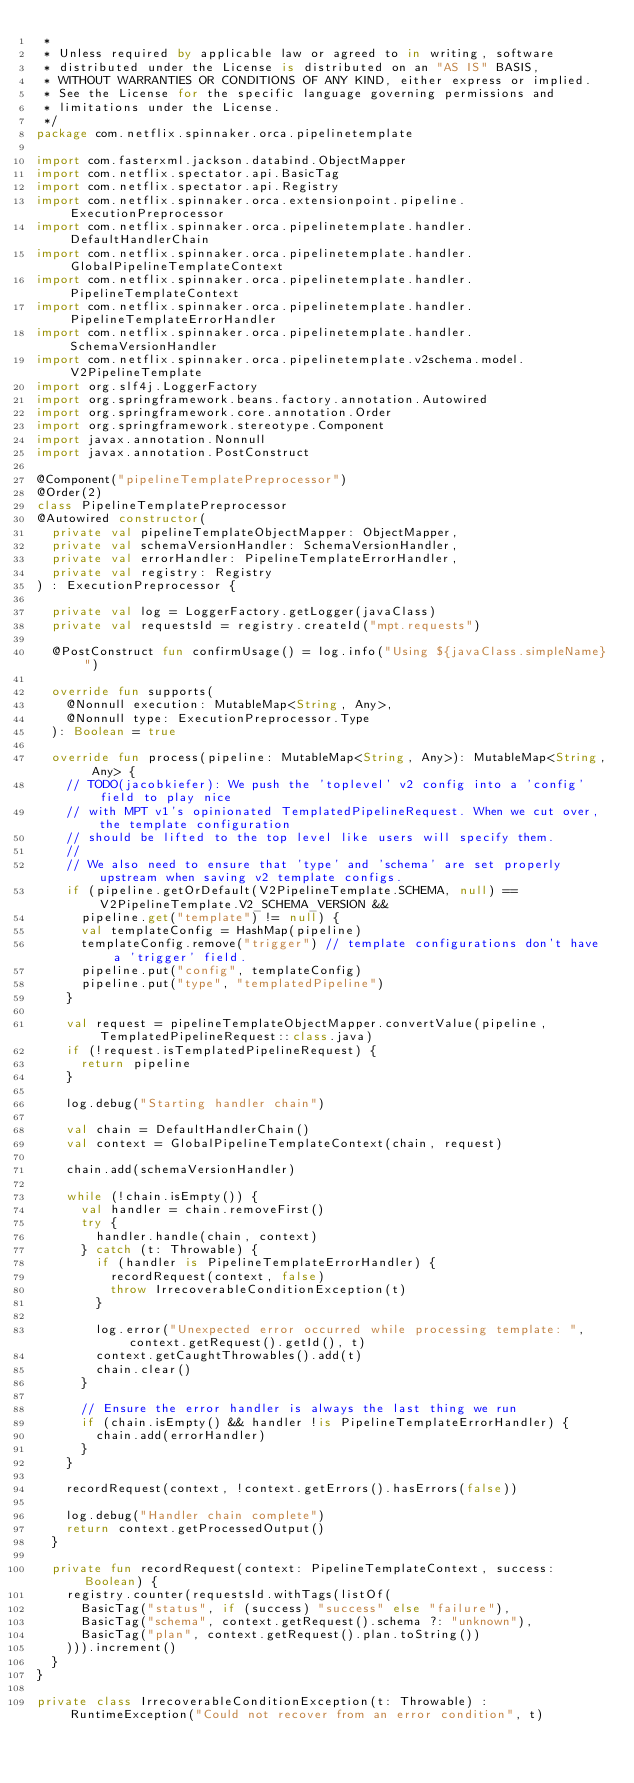<code> <loc_0><loc_0><loc_500><loc_500><_Kotlin_> *
 * Unless required by applicable law or agreed to in writing, software
 * distributed under the License is distributed on an "AS IS" BASIS,
 * WITHOUT WARRANTIES OR CONDITIONS OF ANY KIND, either express or implied.
 * See the License for the specific language governing permissions and
 * limitations under the License.
 */
package com.netflix.spinnaker.orca.pipelinetemplate

import com.fasterxml.jackson.databind.ObjectMapper
import com.netflix.spectator.api.BasicTag
import com.netflix.spectator.api.Registry
import com.netflix.spinnaker.orca.extensionpoint.pipeline.ExecutionPreprocessor
import com.netflix.spinnaker.orca.pipelinetemplate.handler.DefaultHandlerChain
import com.netflix.spinnaker.orca.pipelinetemplate.handler.GlobalPipelineTemplateContext
import com.netflix.spinnaker.orca.pipelinetemplate.handler.PipelineTemplateContext
import com.netflix.spinnaker.orca.pipelinetemplate.handler.PipelineTemplateErrorHandler
import com.netflix.spinnaker.orca.pipelinetemplate.handler.SchemaVersionHandler
import com.netflix.spinnaker.orca.pipelinetemplate.v2schema.model.V2PipelineTemplate
import org.slf4j.LoggerFactory
import org.springframework.beans.factory.annotation.Autowired
import org.springframework.core.annotation.Order
import org.springframework.stereotype.Component
import javax.annotation.Nonnull
import javax.annotation.PostConstruct

@Component("pipelineTemplatePreprocessor")
@Order(2)
class PipelineTemplatePreprocessor
@Autowired constructor(
  private val pipelineTemplateObjectMapper: ObjectMapper,
  private val schemaVersionHandler: SchemaVersionHandler,
  private val errorHandler: PipelineTemplateErrorHandler,
  private val registry: Registry
) : ExecutionPreprocessor {

  private val log = LoggerFactory.getLogger(javaClass)
  private val requestsId = registry.createId("mpt.requests")

  @PostConstruct fun confirmUsage() = log.info("Using ${javaClass.simpleName}")

  override fun supports(
    @Nonnull execution: MutableMap<String, Any>,
    @Nonnull type: ExecutionPreprocessor.Type
  ): Boolean = true

  override fun process(pipeline: MutableMap<String, Any>): MutableMap<String, Any> {
    // TODO(jacobkiefer): We push the 'toplevel' v2 config into a 'config' field to play nice
    // with MPT v1's opinionated TemplatedPipelineRequest. When we cut over, the template configuration
    // should be lifted to the top level like users will specify them.
    //
    // We also need to ensure that 'type' and 'schema' are set properly upstream when saving v2 template configs.
    if (pipeline.getOrDefault(V2PipelineTemplate.SCHEMA, null) == V2PipelineTemplate.V2_SCHEMA_VERSION &&
      pipeline.get("template") != null) {
      val templateConfig = HashMap(pipeline)
      templateConfig.remove("trigger") // template configurations don't have a 'trigger' field.
      pipeline.put("config", templateConfig)
      pipeline.put("type", "templatedPipeline")
    }

    val request = pipelineTemplateObjectMapper.convertValue(pipeline, TemplatedPipelineRequest::class.java)
    if (!request.isTemplatedPipelineRequest) {
      return pipeline
    }

    log.debug("Starting handler chain")

    val chain = DefaultHandlerChain()
    val context = GlobalPipelineTemplateContext(chain, request)

    chain.add(schemaVersionHandler)

    while (!chain.isEmpty()) {
      val handler = chain.removeFirst()
      try {
        handler.handle(chain, context)
      } catch (t: Throwable) {
        if (handler is PipelineTemplateErrorHandler) {
          recordRequest(context, false)
          throw IrrecoverableConditionException(t)
        }

        log.error("Unexpected error occurred while processing template: ", context.getRequest().getId(), t)
        context.getCaughtThrowables().add(t)
        chain.clear()
      }

      // Ensure the error handler is always the last thing we run
      if (chain.isEmpty() && handler !is PipelineTemplateErrorHandler) {
        chain.add(errorHandler)
      }
    }

    recordRequest(context, !context.getErrors().hasErrors(false))

    log.debug("Handler chain complete")
    return context.getProcessedOutput()
  }

  private fun recordRequest(context: PipelineTemplateContext, success: Boolean) {
    registry.counter(requestsId.withTags(listOf(
      BasicTag("status", if (success) "success" else "failure"),
      BasicTag("schema", context.getRequest().schema ?: "unknown"),
      BasicTag("plan", context.getRequest().plan.toString())
    ))).increment()
  }
}

private class IrrecoverableConditionException(t: Throwable) : RuntimeException("Could not recover from an error condition", t)
</code> 